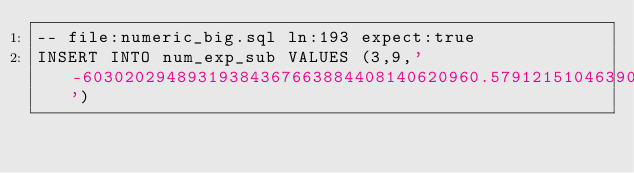Convert code to text. <code><loc_0><loc_0><loc_500><loc_500><_SQL_>-- file:numeric_big.sql ln:193 expect:true
INSERT INTO num_exp_sub VALUES (3,9,'-60302029489319384367663884408140620960.5791215104639085369493197407183130560124286109130354360944260524553172025725325268378015783145476572840273098165721628341015996848028750420770651761919246816300854441592109844750954710317145008297946462099581451150385769713261452744310496166494545449824802407416426304041583975713483424241727236417259479541129474082301376239522310995725648773643946404281422516357503746700705970360169619852905053433235726497292406142332833')
</code> 